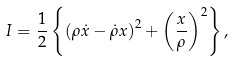<formula> <loc_0><loc_0><loc_500><loc_500>I = \frac { 1 } { 2 } \left \{ \left ( \rho \dot { x } - \dot { \rho } x \right ) ^ { 2 } + \left ( \frac { x } { \rho } \right ) ^ { 2 } \right \} ,</formula> 